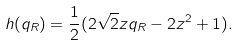<formula> <loc_0><loc_0><loc_500><loc_500>h ( q _ { R } ) = \frac { 1 } { 2 } ( 2 \sqrt { 2 } z q _ { R } - 2 z ^ { 2 } + 1 ) .</formula> 